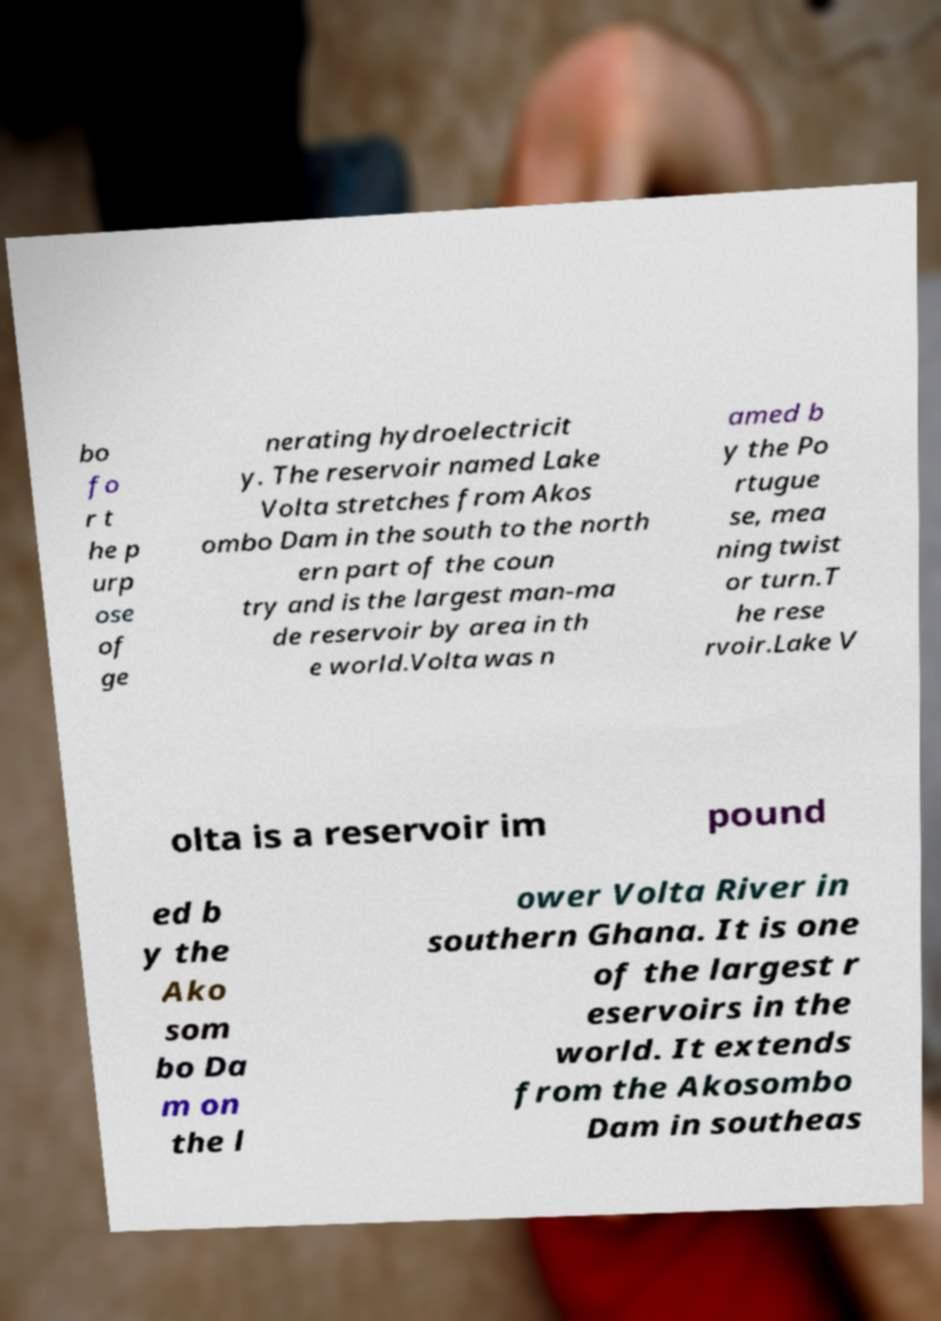Can you read and provide the text displayed in the image?This photo seems to have some interesting text. Can you extract and type it out for me? bo fo r t he p urp ose of ge nerating hydroelectricit y. The reservoir named Lake Volta stretches from Akos ombo Dam in the south to the north ern part of the coun try and is the largest man-ma de reservoir by area in th e world.Volta was n amed b y the Po rtugue se, mea ning twist or turn.T he rese rvoir.Lake V olta is a reservoir im pound ed b y the Ako som bo Da m on the l ower Volta River in southern Ghana. It is one of the largest r eservoirs in the world. It extends from the Akosombo Dam in southeas 